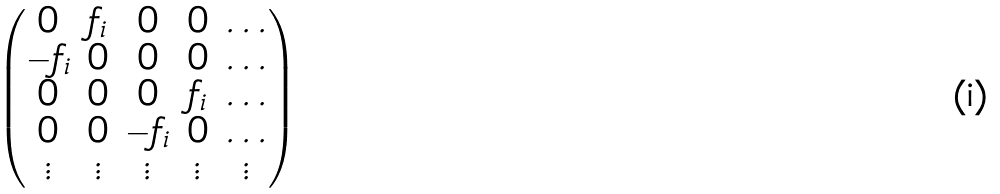<formula> <loc_0><loc_0><loc_500><loc_500>\begin{pmatrix} 0 & f _ { i } & 0 & 0 & \dots \\ - f _ { i } & 0 & 0 & 0 & \dots \\ 0 & 0 & 0 & f _ { i } & \dots \\ 0 & 0 & - f _ { i } & 0 & \dots \\ \vdots & \vdots & \vdots & \vdots & \vdots \end{pmatrix}</formula> 